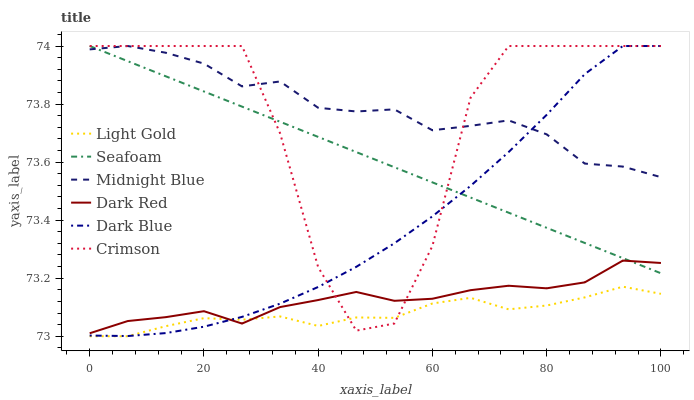Does Light Gold have the minimum area under the curve?
Answer yes or no. Yes. Does Midnight Blue have the maximum area under the curve?
Answer yes or no. Yes. Does Dark Red have the minimum area under the curve?
Answer yes or no. No. Does Dark Red have the maximum area under the curve?
Answer yes or no. No. Is Seafoam the smoothest?
Answer yes or no. Yes. Is Crimson the roughest?
Answer yes or no. Yes. Is Dark Red the smoothest?
Answer yes or no. No. Is Dark Red the roughest?
Answer yes or no. No. Does Light Gold have the lowest value?
Answer yes or no. Yes. Does Dark Red have the lowest value?
Answer yes or no. No. Does Crimson have the highest value?
Answer yes or no. Yes. Does Dark Red have the highest value?
Answer yes or no. No. Is Light Gold less than Seafoam?
Answer yes or no. Yes. Is Midnight Blue greater than Light Gold?
Answer yes or no. Yes. Does Light Gold intersect Crimson?
Answer yes or no. Yes. Is Light Gold less than Crimson?
Answer yes or no. No. Is Light Gold greater than Crimson?
Answer yes or no. No. Does Light Gold intersect Seafoam?
Answer yes or no. No. 